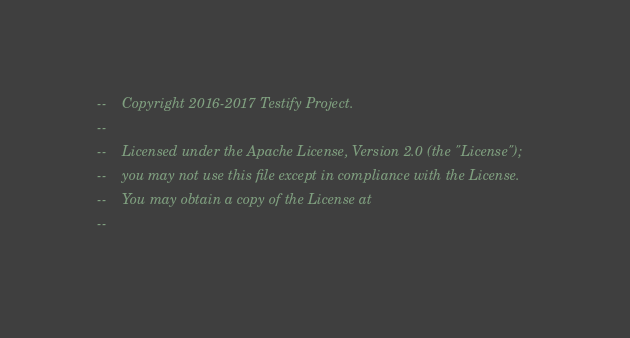<code> <loc_0><loc_0><loc_500><loc_500><_SQL_>--    Copyright 2016-2017 Testify Project.
-- 
--    Licensed under the Apache License, Version 2.0 (the "License");
--    you may not use this file except in compliance with the License.
--    You may obtain a copy of the License at
-- </code> 